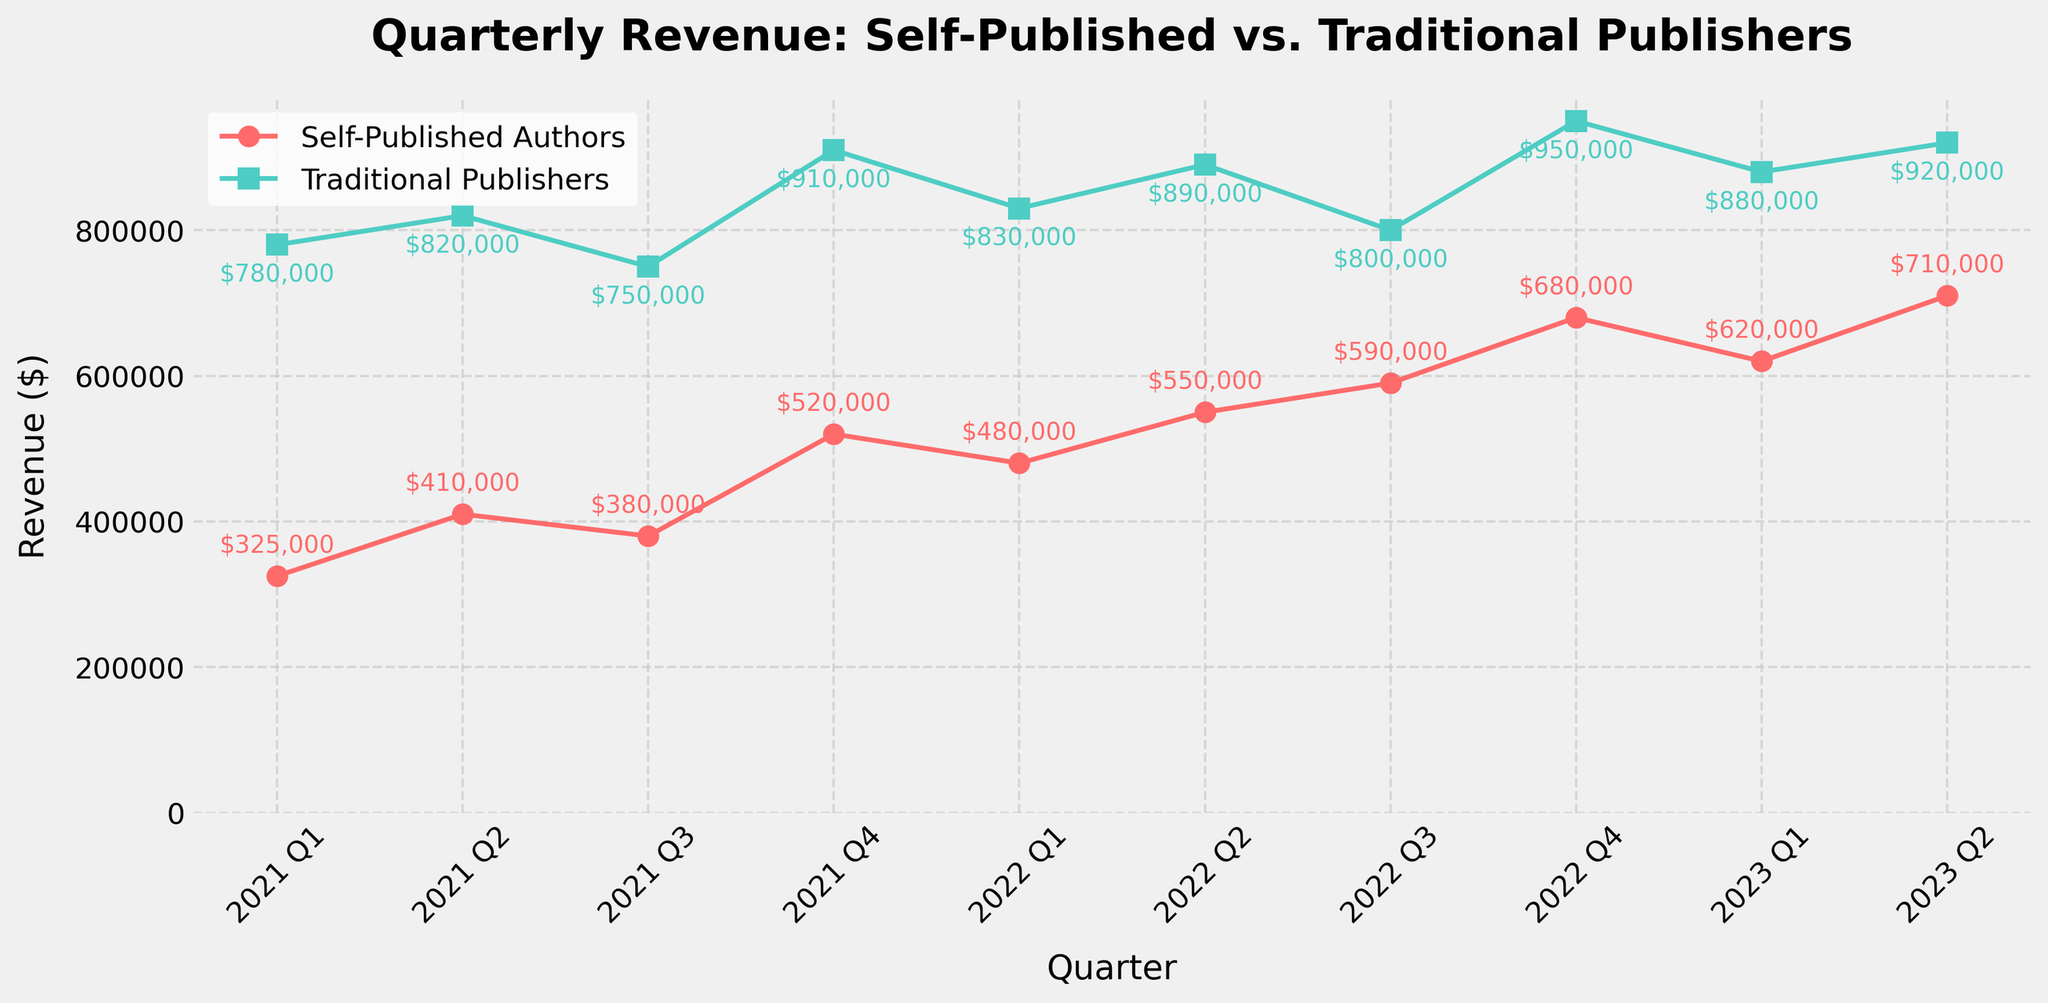What is the revenue difference between Self-Published Authors and Traditional Publishers in 2022 Q4? To determine the revenue difference, look at the values for 2022 Q4. Self-Published Authors have a revenue of $680,000 and Traditional Publishers have $950,000. Subtract the revenue of Self-Published Authors from that of Traditional Publishers: $950,000 - $680,000 = $270,000.
Answer: $270,000 Which quarters saw an increase in revenue for both Self-Published Authors and Traditional Publishers? Compare the revenue figures for consecutive quarters for both Self-Published Authors and Traditional Publishers. For Self-Published Authors, revenue increased from Q1 to Q2, Q3 to Q4 (2021), Q1 to Q2, and Q2 to Q3 (2022). For Traditional Publishers, revenue increased from Q1 to Q2 and Q3 to Q4 (2021), and Q1 to Q2, and Q2 to Q4 (2022). The common periods are Q1 to Q2 (2021), and Q2 to Q3 and Q2 to Q4 (2022).
Answer: 2021 Q1-Q2, 2022 Q2-Q3, 2022 Q2-Q4 Which quarter had the highest revenue for Self-Published Authors? Look at the data points for all quarters and identify the highest value for Self-Published Authors. The highest revenue is $710,000 in 2023 Q2.
Answer: 2023 Q2 In which quarter did Traditional Publishers' revenue see the largest drop compared to the previous quarter? Find the differences in revenue values between consecutive quarters for Traditional Publishers. The largest drop is between 2021 Q2 ($820,000) and 2021 Q3 ($750,000), which is a decrease of $70,000.
Answer: 2021 Q3 What was the total revenue for Self-Published Authors in 2022? Sum the quarterly revenues for Self-Published Authors in 2022: $480,000 (Q1) + $550,000 (Q2) + $590,000 (Q3) + $680,000 (Q4) = $2,300,000.
Answer: $2,300,000 Did the revenue for Traditional Publishers ever fall below the highest revenue of Self-Published Authors? Identify the highest revenue for Self-Published Authors ($710,000 in 2023 Q2) and check if any quarterly revenue for Traditional Publishers is below this figure. There are no values for Traditional Publishers below $710,000 in the provided data.
Answer: No How much did the revenue for Self-Published Authors increase from 2021 Q1 to 2023 Q2? Subtract the revenue in 2021 Q1 ($325,000) from the revenue in 2023 Q2 ($710,000) for Self-Published Authors: $710,000 - $325,000 = $385,000.
Answer: $385,000 What is the average quarterly revenue for Traditional Publishers across the entire period? Sum the revenues for Traditional Publishers across all quarters and divide by the number of quarters (10). The sum is $780,000 + $820,000 + $750,000 + $910,000 + $830,000 + $890,000 + $800,000 + $950,000 + $880,000 + $920,000 = $8,530,000. The average is $8,530,000 / 10 = $853,000.
Answer: $853,000 